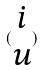Convert formula to latex. <formula><loc_0><loc_0><loc_500><loc_500>( \begin{matrix} i \\ u \end{matrix} )</formula> 